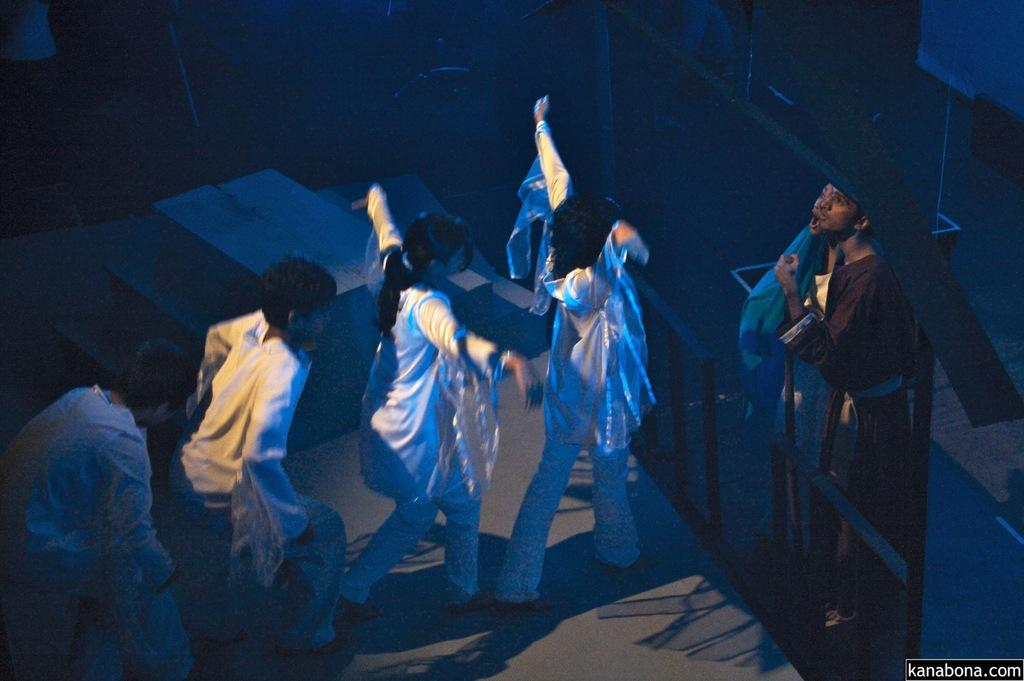What activity are the people in the image engaged in? The people in the image are performing on the stage. What architectural feature can be seen in the image? There are stairs in the image. What type of objects are present in the image? There are rods in the image. Can you describe any other objects or features in the image? There are objects in the image, but their specific nature is not mentioned in the facts. Is there any text or marking in the image? Yes, there is a watermark in the bottom right corner of the image. What type of song is being sung by the lizards in the image? There are no lizards present in the image, and therefore no singing can be observed. 